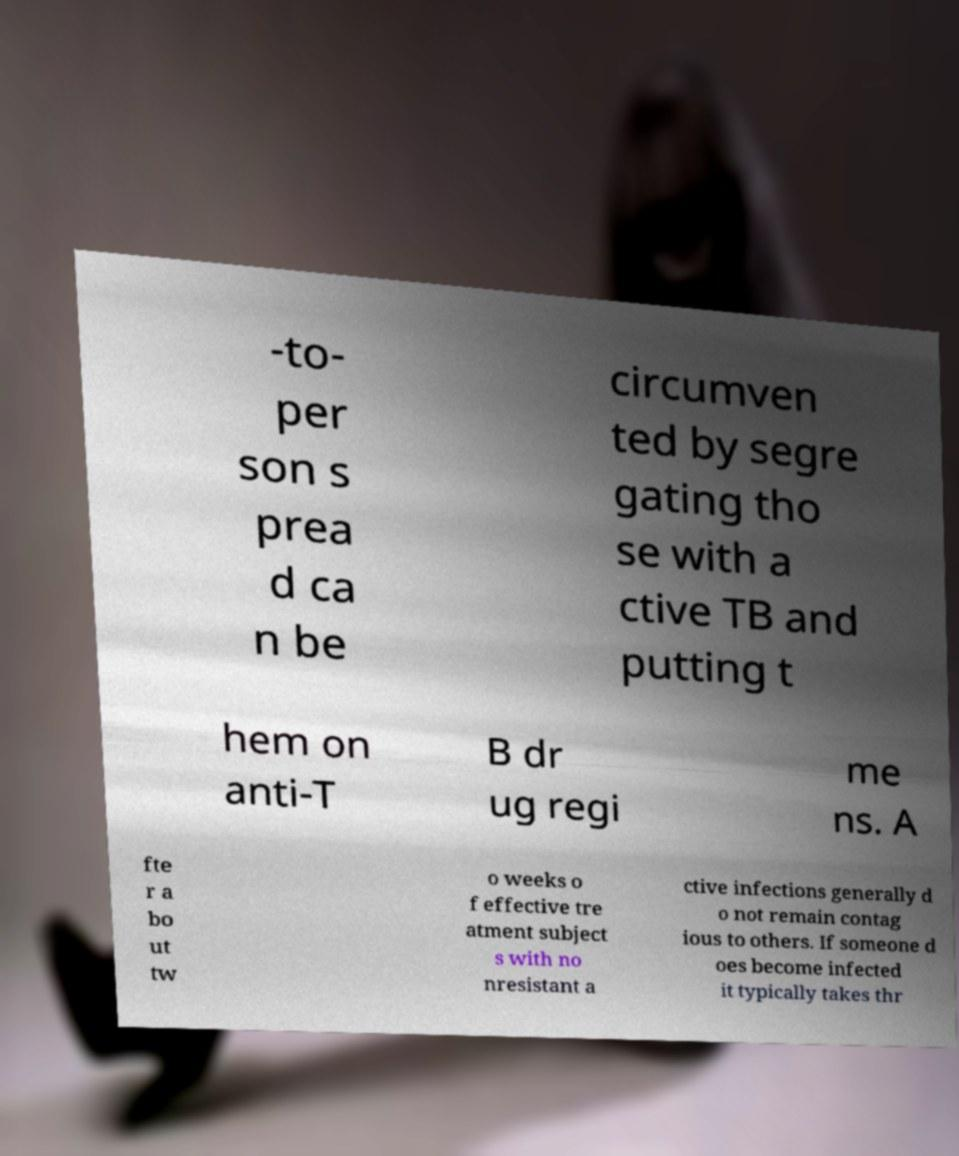Please read and relay the text visible in this image. What does it say? -to- per son s prea d ca n be circumven ted by segre gating tho se with a ctive TB and putting t hem on anti-T B dr ug regi me ns. A fte r a bo ut tw o weeks o f effective tre atment subject s with no nresistant a ctive infections generally d o not remain contag ious to others. If someone d oes become infected it typically takes thr 